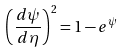Convert formula to latex. <formula><loc_0><loc_0><loc_500><loc_500>\left ( \frac { d \psi } { d \eta } \right ) ^ { 2 } = 1 - e ^ { \psi }</formula> 